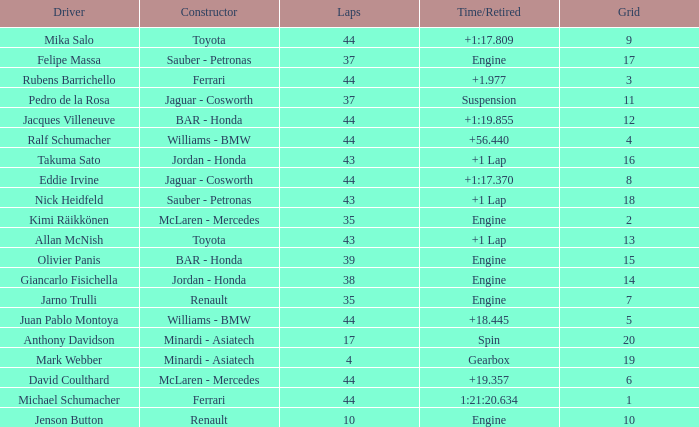What was the retired time on someone who had 43 laps on a grip of 18? +1 Lap. Give me the full table as a dictionary. {'header': ['Driver', 'Constructor', 'Laps', 'Time/Retired', 'Grid'], 'rows': [['Mika Salo', 'Toyota', '44', '+1:17.809', '9'], ['Felipe Massa', 'Sauber - Petronas', '37', 'Engine', '17'], ['Rubens Barrichello', 'Ferrari', '44', '+1.977', '3'], ['Pedro de la Rosa', 'Jaguar - Cosworth', '37', 'Suspension', '11'], ['Jacques Villeneuve', 'BAR - Honda', '44', '+1:19.855', '12'], ['Ralf Schumacher', 'Williams - BMW', '44', '+56.440', '4'], ['Takuma Sato', 'Jordan - Honda', '43', '+1 Lap', '16'], ['Eddie Irvine', 'Jaguar - Cosworth', '44', '+1:17.370', '8'], ['Nick Heidfeld', 'Sauber - Petronas', '43', '+1 Lap', '18'], ['Kimi Räikkönen', 'McLaren - Mercedes', '35', 'Engine', '2'], ['Allan McNish', 'Toyota', '43', '+1 Lap', '13'], ['Olivier Panis', 'BAR - Honda', '39', 'Engine', '15'], ['Giancarlo Fisichella', 'Jordan - Honda', '38', 'Engine', '14'], ['Jarno Trulli', 'Renault', '35', 'Engine', '7'], ['Juan Pablo Montoya', 'Williams - BMW', '44', '+18.445', '5'], ['Anthony Davidson', 'Minardi - Asiatech', '17', 'Spin', '20'], ['Mark Webber', 'Minardi - Asiatech', '4', 'Gearbox', '19'], ['David Coulthard', 'McLaren - Mercedes', '44', '+19.357', '6'], ['Michael Schumacher', 'Ferrari', '44', '1:21:20.634', '1'], ['Jenson Button', 'Renault', '10', 'Engine', '10']]} 